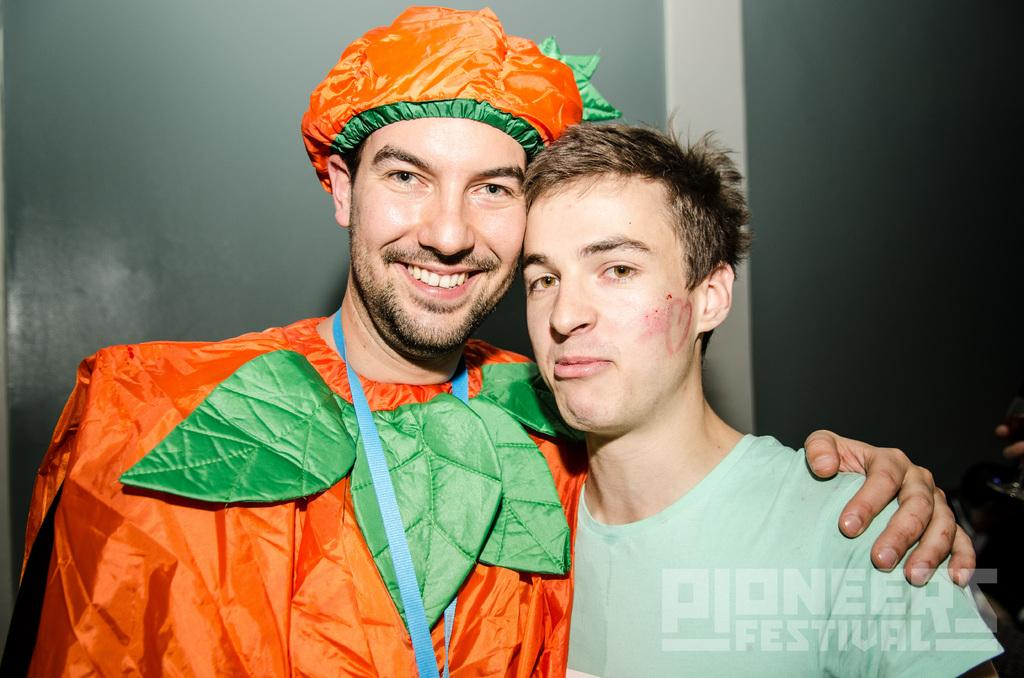How many people are in the image? There are people in the image, but the exact number is not specified. What is unique about one person's appearance in the image? One person is wearing a costume. What can be seen behind the people in the image? There is a wall in the background of the image. What is located in the bottom right corner of the image? There is some text visible in the bottom right corner of the image. What type of plantation can be seen in the image? There is no plantation present in the image. What knowledge is being shared among the people in the image? The facts provided do not give any information about knowledge being shared among the people in the image. 